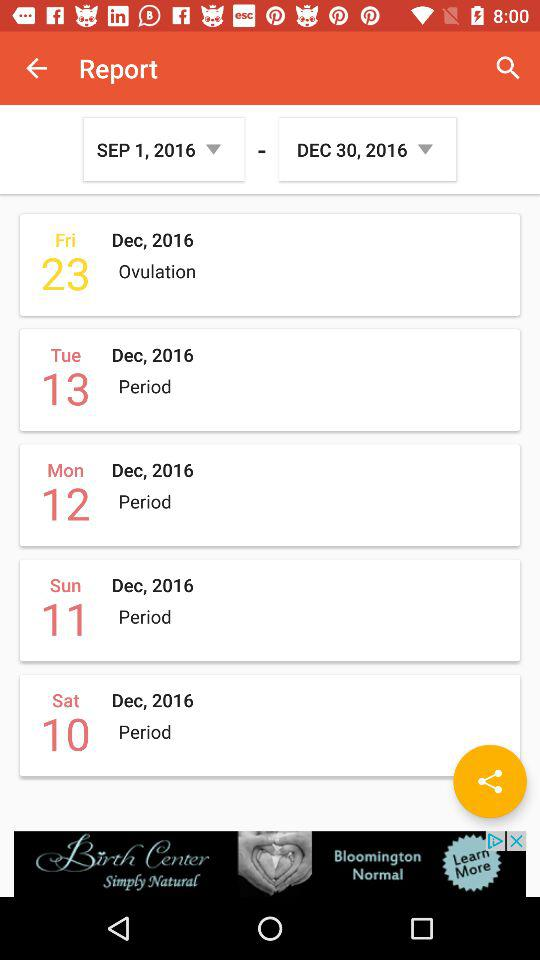What is the date mentioned for ovulation? The mentioned date for ovulation is Friday, December 23, 2016. 